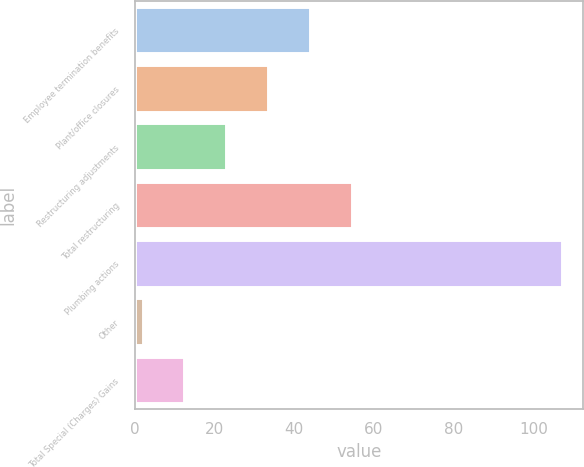Convert chart to OTSL. <chart><loc_0><loc_0><loc_500><loc_500><bar_chart><fcel>Employee termination benefits<fcel>Plant/office closures<fcel>Restructuring adjustments<fcel>Total restructuring<fcel>Plumbing actions<fcel>Other<fcel>Total Special (Charges) Gains<nl><fcel>44<fcel>33.5<fcel>23<fcel>54.5<fcel>107<fcel>2<fcel>12.5<nl></chart> 